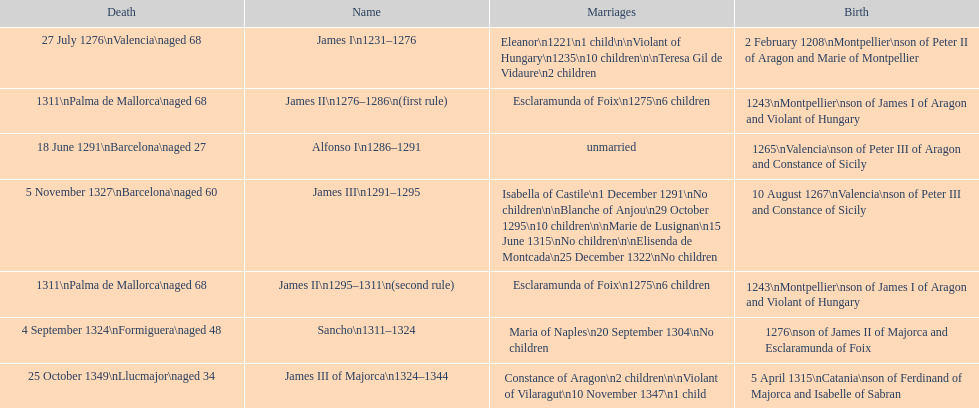Which monarch is listed first? James I 1231-1276. 